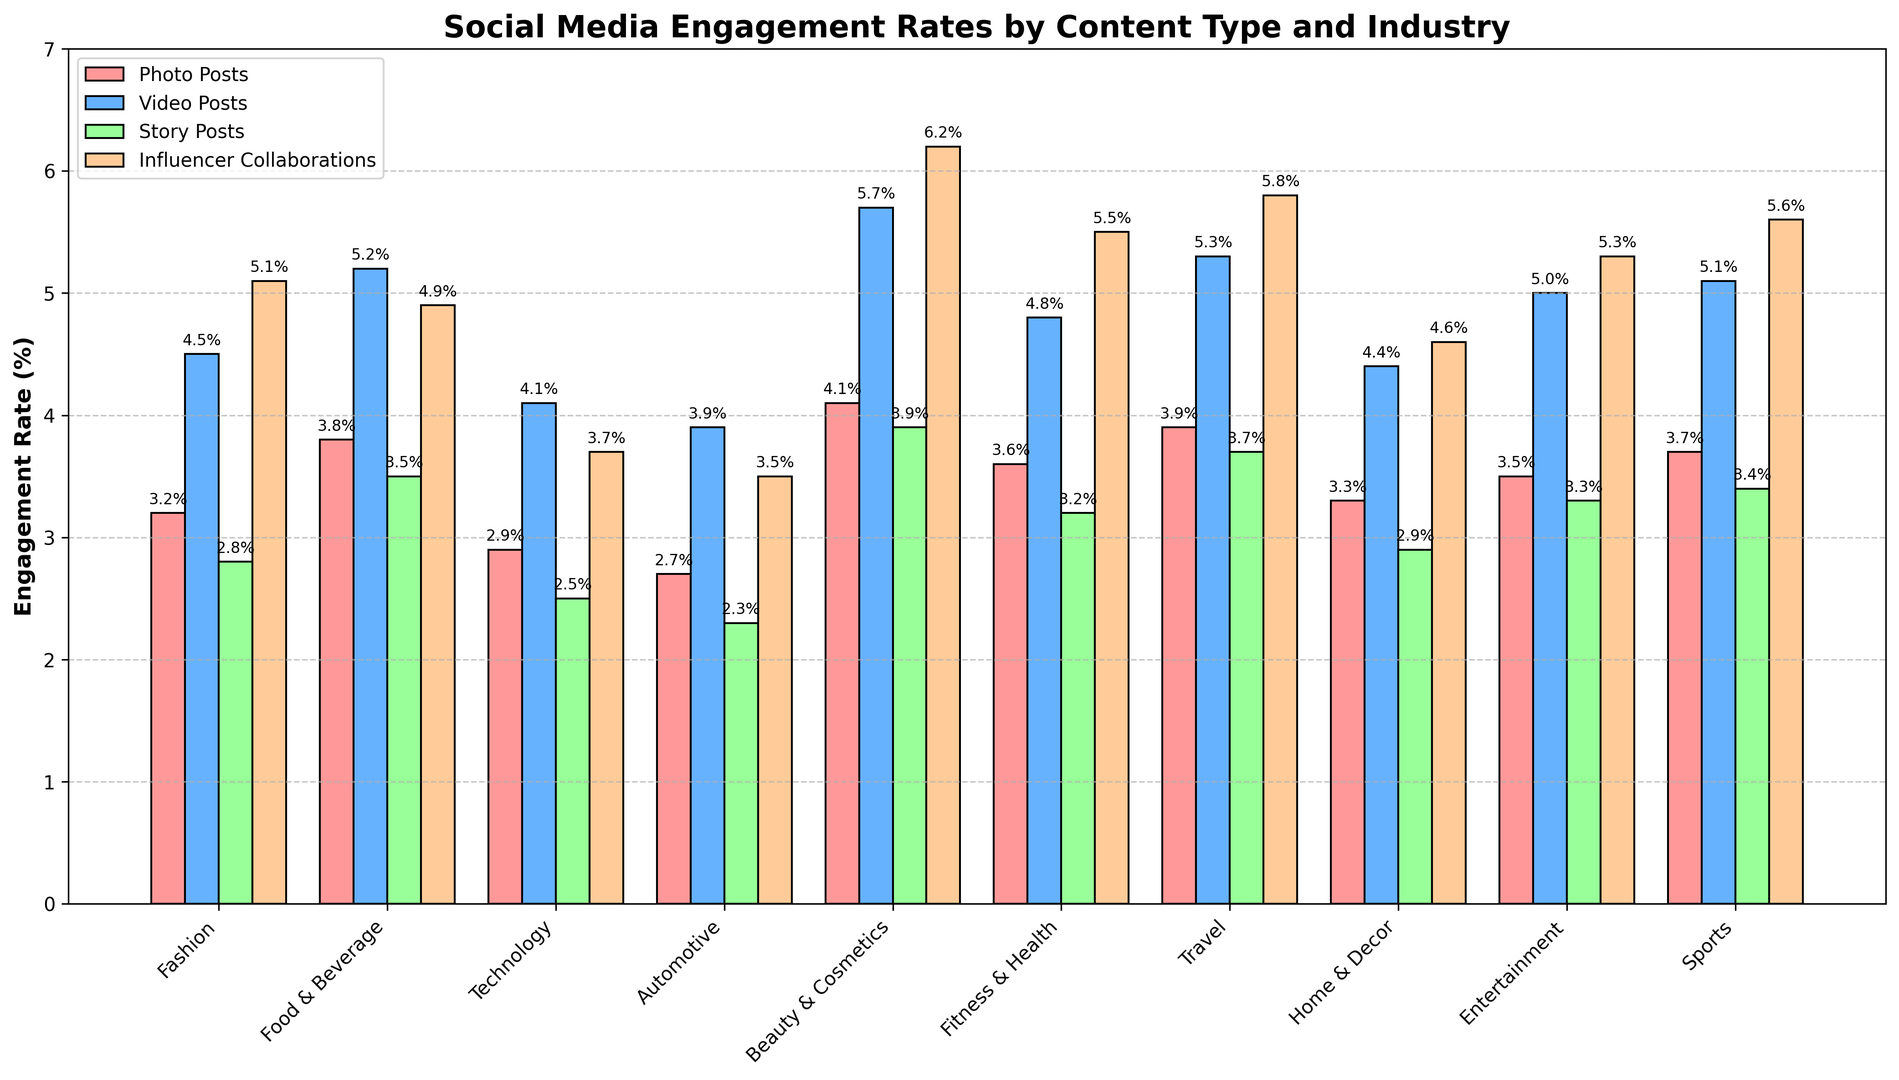Which type of sponsored content has the highest average engagement rate across industries? To find the answer, calculate the average engagement rate for each type of content by adding up the values for all industries and then dividing by the number of industries. The highest average value identifies the sponsored content with the highest engagement rate.
Answer: Influencer Collaborations Which industry has the lowest engagement rate for story posts? Look at the "Story Posts" column and find the smallest value. Then, identify the corresponding industry in the "Type" column.
Answer: Automotive Is the engagement rate for video posts in the beauty & cosmetics industry higher than the engagement rate for influencer collaborations in the food & beverage industry? Compare the value for "Video Posts" in the beauty & cosmetics row with the value for "Influencer Collaborations" in the food & beverage row. 5.7 vs. 4.9, respectively
Answer: Yes By how much does the engagement rate for influencer collaborations in the sports industry exceed that in the automotive industry? Subtract the value for "Influencer Collaborations" in the automotive industry from the value in the sports industry. 5.6 - 3.5 = 2.1
Answer: 2.1 In which industry do video posts have a greater engagement rate than photo posts by at least 1.5 percentage points? For each industry, subtract the value of "Photo Posts" from "Video Posts" and see if the difference is 1.5 or more. The industries are Food & Beverage (5.2 - 3.8 = 1.4, not enough), Beauty & Cosmetics (5.7 - 4.1 = 1.6), Travel (5.3 - 3.9 = 1.4, not enough).
Answer: Beauty & Cosmetics What's the difference in engagement rates between story posts and photo posts for the travel industry? Subtract the value for "Photo Posts" from "Story Posts" in the travel industry. 3.7 - 3.9 = -0.2
Answer: -0.2 Are video posts or photo posts more engaging on average across all industries? Calculate the average engagement rate for video posts and photo posts across all industries. For video posts: (4.5 + 5.2 + 4.1 + 3.9 + 5.7 + 4.8 + 5.3 + 4.4 + 5.0 + 5.1) / 10 = 4.8. For photo posts: (3.2 + 3.8 + 2.9 + 2.7 + 4.1 + 3.6 + 3.9 + 3.3 + 3.5 + 3.7)/10 = 3.47. Video posts have a higher average engagement.
Answer: Video Posts Which content type shows the largest visual variation in engagement rates across different industries? Visually inspect the grouped bar plot and compare the heights of the bars for each content type across all industries. Influencer Collaborations show the largest variation as the differences between the smallest and largest bars are most prominent.
Answer: Influencer Collaborations 